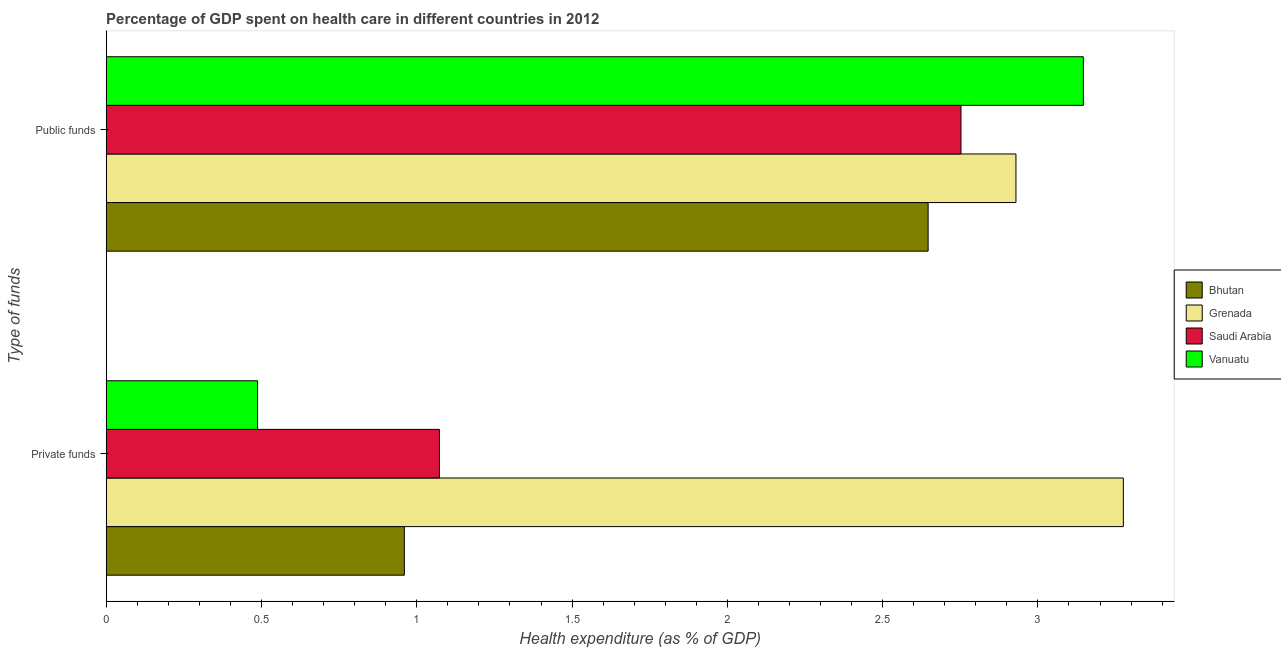How many different coloured bars are there?
Your answer should be very brief. 4. How many groups of bars are there?
Provide a short and direct response. 2. Are the number of bars on each tick of the Y-axis equal?
Keep it short and to the point. Yes. How many bars are there on the 2nd tick from the bottom?
Keep it short and to the point. 4. What is the label of the 1st group of bars from the top?
Keep it short and to the point. Public funds. What is the amount of private funds spent in healthcare in Vanuatu?
Provide a short and direct response. 0.49. Across all countries, what is the maximum amount of private funds spent in healthcare?
Keep it short and to the point. 3.28. Across all countries, what is the minimum amount of public funds spent in healthcare?
Provide a short and direct response. 2.65. In which country was the amount of private funds spent in healthcare maximum?
Your answer should be compact. Grenada. In which country was the amount of private funds spent in healthcare minimum?
Provide a short and direct response. Vanuatu. What is the total amount of public funds spent in healthcare in the graph?
Ensure brevity in your answer.  11.47. What is the difference between the amount of public funds spent in healthcare in Saudi Arabia and that in Vanuatu?
Your answer should be very brief. -0.39. What is the difference between the amount of private funds spent in healthcare in Vanuatu and the amount of public funds spent in healthcare in Bhutan?
Make the answer very short. -2.16. What is the average amount of private funds spent in healthcare per country?
Your answer should be compact. 1.45. What is the difference between the amount of public funds spent in healthcare and amount of private funds spent in healthcare in Grenada?
Offer a terse response. -0.35. What is the ratio of the amount of private funds spent in healthcare in Grenada to that in Vanuatu?
Provide a succinct answer. 6.72. What does the 1st bar from the top in Private funds represents?
Keep it short and to the point. Vanuatu. What does the 1st bar from the bottom in Private funds represents?
Offer a very short reply. Bhutan. What is the difference between two consecutive major ticks on the X-axis?
Provide a short and direct response. 0.5. Where does the legend appear in the graph?
Your answer should be very brief. Center right. How are the legend labels stacked?
Keep it short and to the point. Vertical. What is the title of the graph?
Your answer should be compact. Percentage of GDP spent on health care in different countries in 2012. Does "Colombia" appear as one of the legend labels in the graph?
Offer a very short reply. No. What is the label or title of the X-axis?
Provide a short and direct response. Health expenditure (as % of GDP). What is the label or title of the Y-axis?
Make the answer very short. Type of funds. What is the Health expenditure (as % of GDP) of Bhutan in Private funds?
Ensure brevity in your answer.  0.96. What is the Health expenditure (as % of GDP) in Grenada in Private funds?
Your answer should be very brief. 3.28. What is the Health expenditure (as % of GDP) of Saudi Arabia in Private funds?
Offer a terse response. 1.07. What is the Health expenditure (as % of GDP) of Vanuatu in Private funds?
Your response must be concise. 0.49. What is the Health expenditure (as % of GDP) in Bhutan in Public funds?
Your response must be concise. 2.65. What is the Health expenditure (as % of GDP) in Grenada in Public funds?
Offer a terse response. 2.93. What is the Health expenditure (as % of GDP) of Saudi Arabia in Public funds?
Your response must be concise. 2.75. What is the Health expenditure (as % of GDP) in Vanuatu in Public funds?
Your response must be concise. 3.15. Across all Type of funds, what is the maximum Health expenditure (as % of GDP) in Bhutan?
Make the answer very short. 2.65. Across all Type of funds, what is the maximum Health expenditure (as % of GDP) of Grenada?
Keep it short and to the point. 3.28. Across all Type of funds, what is the maximum Health expenditure (as % of GDP) in Saudi Arabia?
Provide a succinct answer. 2.75. Across all Type of funds, what is the maximum Health expenditure (as % of GDP) in Vanuatu?
Offer a very short reply. 3.15. Across all Type of funds, what is the minimum Health expenditure (as % of GDP) in Bhutan?
Give a very brief answer. 0.96. Across all Type of funds, what is the minimum Health expenditure (as % of GDP) of Grenada?
Your answer should be compact. 2.93. Across all Type of funds, what is the minimum Health expenditure (as % of GDP) in Saudi Arabia?
Ensure brevity in your answer.  1.07. Across all Type of funds, what is the minimum Health expenditure (as % of GDP) in Vanuatu?
Ensure brevity in your answer.  0.49. What is the total Health expenditure (as % of GDP) of Bhutan in the graph?
Make the answer very short. 3.61. What is the total Health expenditure (as % of GDP) in Grenada in the graph?
Ensure brevity in your answer.  6.2. What is the total Health expenditure (as % of GDP) in Saudi Arabia in the graph?
Offer a very short reply. 3.83. What is the total Health expenditure (as % of GDP) of Vanuatu in the graph?
Give a very brief answer. 3.63. What is the difference between the Health expenditure (as % of GDP) in Bhutan in Private funds and that in Public funds?
Offer a very short reply. -1.69. What is the difference between the Health expenditure (as % of GDP) in Grenada in Private funds and that in Public funds?
Make the answer very short. 0.35. What is the difference between the Health expenditure (as % of GDP) of Saudi Arabia in Private funds and that in Public funds?
Your answer should be very brief. -1.68. What is the difference between the Health expenditure (as % of GDP) of Vanuatu in Private funds and that in Public funds?
Your answer should be compact. -2.66. What is the difference between the Health expenditure (as % of GDP) in Bhutan in Private funds and the Health expenditure (as % of GDP) in Grenada in Public funds?
Make the answer very short. -1.97. What is the difference between the Health expenditure (as % of GDP) in Bhutan in Private funds and the Health expenditure (as % of GDP) in Saudi Arabia in Public funds?
Offer a very short reply. -1.79. What is the difference between the Health expenditure (as % of GDP) of Bhutan in Private funds and the Health expenditure (as % of GDP) of Vanuatu in Public funds?
Provide a succinct answer. -2.19. What is the difference between the Health expenditure (as % of GDP) in Grenada in Private funds and the Health expenditure (as % of GDP) in Saudi Arabia in Public funds?
Provide a succinct answer. 0.52. What is the difference between the Health expenditure (as % of GDP) of Grenada in Private funds and the Health expenditure (as % of GDP) of Vanuatu in Public funds?
Give a very brief answer. 0.13. What is the difference between the Health expenditure (as % of GDP) of Saudi Arabia in Private funds and the Health expenditure (as % of GDP) of Vanuatu in Public funds?
Your answer should be compact. -2.07. What is the average Health expenditure (as % of GDP) of Bhutan per Type of funds?
Provide a succinct answer. 1.8. What is the average Health expenditure (as % of GDP) of Grenada per Type of funds?
Give a very brief answer. 3.1. What is the average Health expenditure (as % of GDP) of Saudi Arabia per Type of funds?
Give a very brief answer. 1.91. What is the average Health expenditure (as % of GDP) in Vanuatu per Type of funds?
Your answer should be very brief. 1.82. What is the difference between the Health expenditure (as % of GDP) of Bhutan and Health expenditure (as % of GDP) of Grenada in Private funds?
Offer a terse response. -2.32. What is the difference between the Health expenditure (as % of GDP) in Bhutan and Health expenditure (as % of GDP) in Saudi Arabia in Private funds?
Your answer should be very brief. -0.11. What is the difference between the Health expenditure (as % of GDP) of Bhutan and Health expenditure (as % of GDP) of Vanuatu in Private funds?
Your answer should be very brief. 0.47. What is the difference between the Health expenditure (as % of GDP) in Grenada and Health expenditure (as % of GDP) in Saudi Arabia in Private funds?
Ensure brevity in your answer.  2.2. What is the difference between the Health expenditure (as % of GDP) of Grenada and Health expenditure (as % of GDP) of Vanuatu in Private funds?
Provide a short and direct response. 2.79. What is the difference between the Health expenditure (as % of GDP) in Saudi Arabia and Health expenditure (as % of GDP) in Vanuatu in Private funds?
Keep it short and to the point. 0.59. What is the difference between the Health expenditure (as % of GDP) in Bhutan and Health expenditure (as % of GDP) in Grenada in Public funds?
Your answer should be compact. -0.28. What is the difference between the Health expenditure (as % of GDP) in Bhutan and Health expenditure (as % of GDP) in Saudi Arabia in Public funds?
Ensure brevity in your answer.  -0.11. What is the difference between the Health expenditure (as % of GDP) in Bhutan and Health expenditure (as % of GDP) in Vanuatu in Public funds?
Your response must be concise. -0.5. What is the difference between the Health expenditure (as % of GDP) of Grenada and Health expenditure (as % of GDP) of Saudi Arabia in Public funds?
Ensure brevity in your answer.  0.18. What is the difference between the Health expenditure (as % of GDP) of Grenada and Health expenditure (as % of GDP) of Vanuatu in Public funds?
Offer a terse response. -0.22. What is the difference between the Health expenditure (as % of GDP) in Saudi Arabia and Health expenditure (as % of GDP) in Vanuatu in Public funds?
Your answer should be very brief. -0.39. What is the ratio of the Health expenditure (as % of GDP) in Bhutan in Private funds to that in Public funds?
Your answer should be very brief. 0.36. What is the ratio of the Health expenditure (as % of GDP) of Grenada in Private funds to that in Public funds?
Offer a terse response. 1.12. What is the ratio of the Health expenditure (as % of GDP) in Saudi Arabia in Private funds to that in Public funds?
Offer a very short reply. 0.39. What is the ratio of the Health expenditure (as % of GDP) of Vanuatu in Private funds to that in Public funds?
Give a very brief answer. 0.15. What is the difference between the highest and the second highest Health expenditure (as % of GDP) in Bhutan?
Ensure brevity in your answer.  1.69. What is the difference between the highest and the second highest Health expenditure (as % of GDP) of Grenada?
Offer a terse response. 0.35. What is the difference between the highest and the second highest Health expenditure (as % of GDP) of Saudi Arabia?
Ensure brevity in your answer.  1.68. What is the difference between the highest and the second highest Health expenditure (as % of GDP) in Vanuatu?
Give a very brief answer. 2.66. What is the difference between the highest and the lowest Health expenditure (as % of GDP) of Bhutan?
Provide a succinct answer. 1.69. What is the difference between the highest and the lowest Health expenditure (as % of GDP) of Grenada?
Provide a succinct answer. 0.35. What is the difference between the highest and the lowest Health expenditure (as % of GDP) in Saudi Arabia?
Offer a very short reply. 1.68. What is the difference between the highest and the lowest Health expenditure (as % of GDP) in Vanuatu?
Your response must be concise. 2.66. 